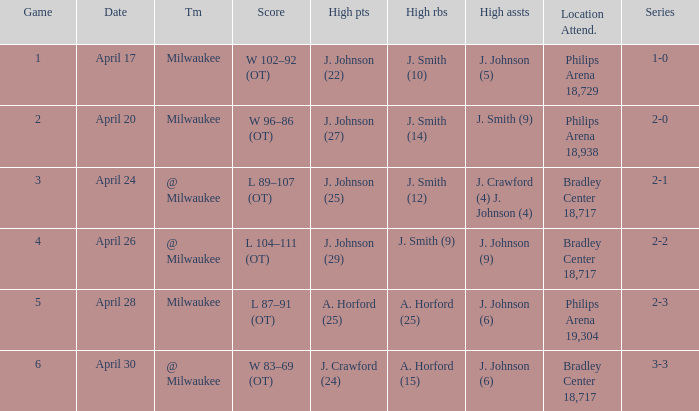What was the score in game 6? W 83–69 (OT). 